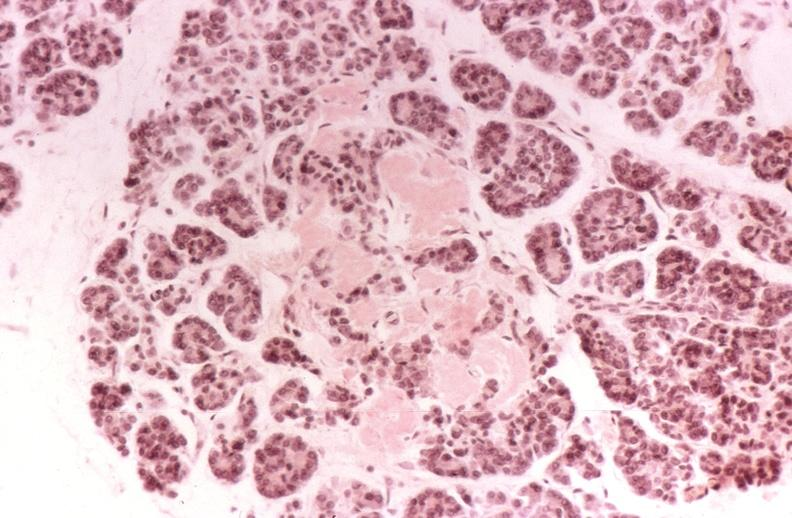does this image show kidney, glomerular amyloid, diabetes mellitus?
Answer the question using a single word or phrase. Yes 